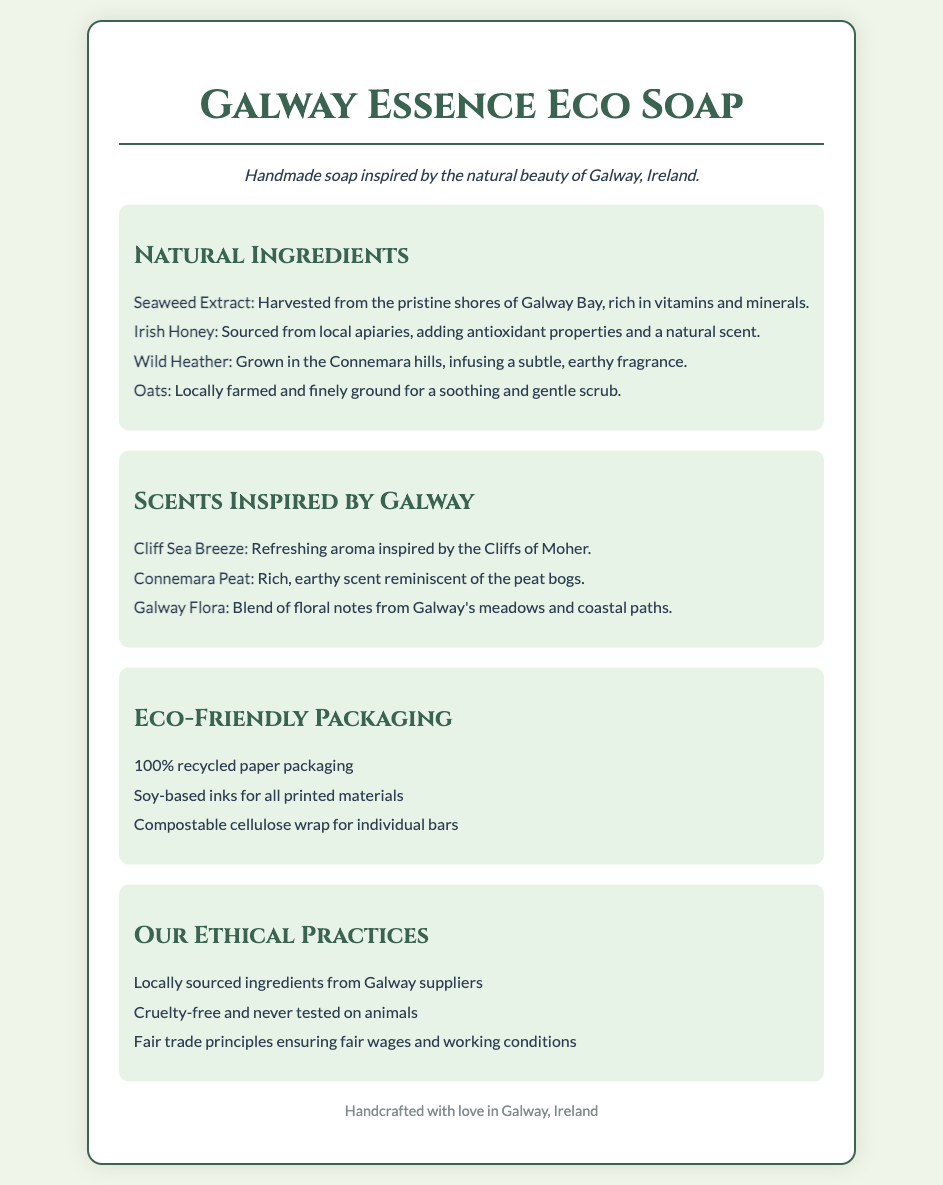What are the primary ingredients in the soap? The primary ingredients are listed under "Natural Ingredients" in the document, which include Seaweed Extract, Irish Honey, Wild Heather, and Oats.
Answer: Seaweed Extract, Irish Honey, Wild Heather, Oats What scent is inspired by the Cliffs of Moher? The scent inspired by the Cliffs of Moher is mentioned in the "Scents Inspired by Galway" section.
Answer: Cliff Sea Breeze What type of packaging is used for individual bars? The packaging type for individual bars is mentioned in the "Eco-Friendly Packaging" section, which describes the wrap used.
Answer: Compostable cellulose wrap From where is the Irish Honey sourced? The source of the Irish Honey is stated in the "Natural Ingredients" section.
Answer: Local apiaries How many eco-friendly packaging materials are listed? The number of eco-friendly packaging materials can be found in the "Eco-Friendly Packaging" section by counting the items presented.
Answer: Three Why are the ingredients sourced locally? The reasoning behind sourcing ingredients locally is related to the ethical practices shared in the document that emphasize supporting local suppliers.
Answer: To support local suppliers What style of font is used for the headings? The document specifies a particular font used for headings in its styling section.
Answer: Cinzel Is the soap tested on animals? The document addresses the ethical practices regarding testing on animals in the "Our Ethical Practices" section.
Answer: No 